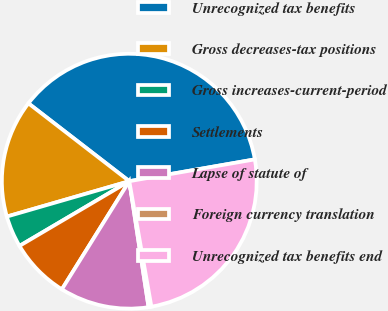Convert chart. <chart><loc_0><loc_0><loc_500><loc_500><pie_chart><fcel>Unrecognized tax benefits<fcel>Gross decreases-tax positions<fcel>Gross increases-current-period<fcel>Settlements<fcel>Lapse of statute of<fcel>Foreign currency translation<fcel>Unrecognized tax benefits end<nl><fcel>36.8%<fcel>14.94%<fcel>4.0%<fcel>7.65%<fcel>11.29%<fcel>0.36%<fcel>24.96%<nl></chart> 